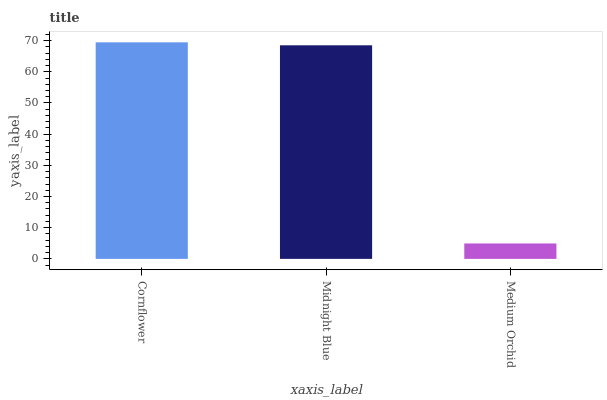Is Medium Orchid the minimum?
Answer yes or no. Yes. Is Cornflower the maximum?
Answer yes or no. Yes. Is Midnight Blue the minimum?
Answer yes or no. No. Is Midnight Blue the maximum?
Answer yes or no. No. Is Cornflower greater than Midnight Blue?
Answer yes or no. Yes. Is Midnight Blue less than Cornflower?
Answer yes or no. Yes. Is Midnight Blue greater than Cornflower?
Answer yes or no. No. Is Cornflower less than Midnight Blue?
Answer yes or no. No. Is Midnight Blue the high median?
Answer yes or no. Yes. Is Midnight Blue the low median?
Answer yes or no. Yes. Is Medium Orchid the high median?
Answer yes or no. No. Is Medium Orchid the low median?
Answer yes or no. No. 